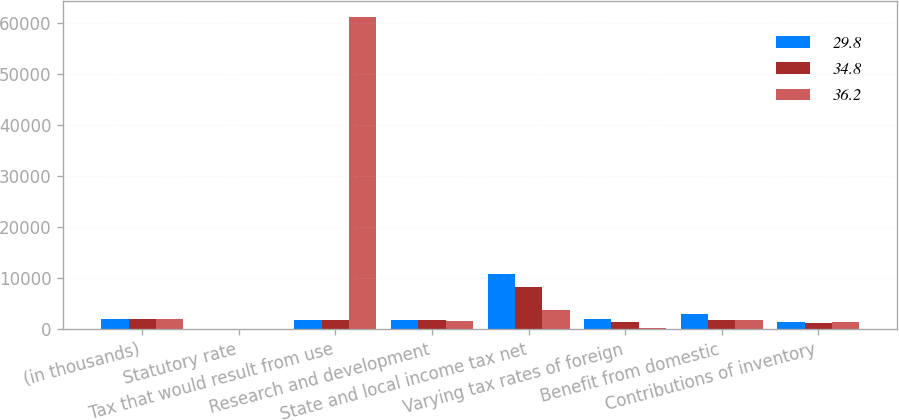Convert chart to OTSL. <chart><loc_0><loc_0><loc_500><loc_500><stacked_bar_chart><ecel><fcel>(in thousands)<fcel>Statutory rate<fcel>Tax that would result from use<fcel>Research and development<fcel>State and local income tax net<fcel>Varying tax rates of foreign<fcel>Benefit from domestic<fcel>Contributions of inventory<nl><fcel>29.8<fcel>2007<fcel>35<fcel>1797<fcel>1794<fcel>10810<fcel>1850<fcel>3018<fcel>1304<nl><fcel>34.8<fcel>2006<fcel>35<fcel>1797<fcel>1800<fcel>8140<fcel>1448<fcel>1749<fcel>1074<nl><fcel>36.2<fcel>2005<fcel>35<fcel>61241<fcel>1550<fcel>3787<fcel>200<fcel>1840<fcel>1354<nl></chart> 